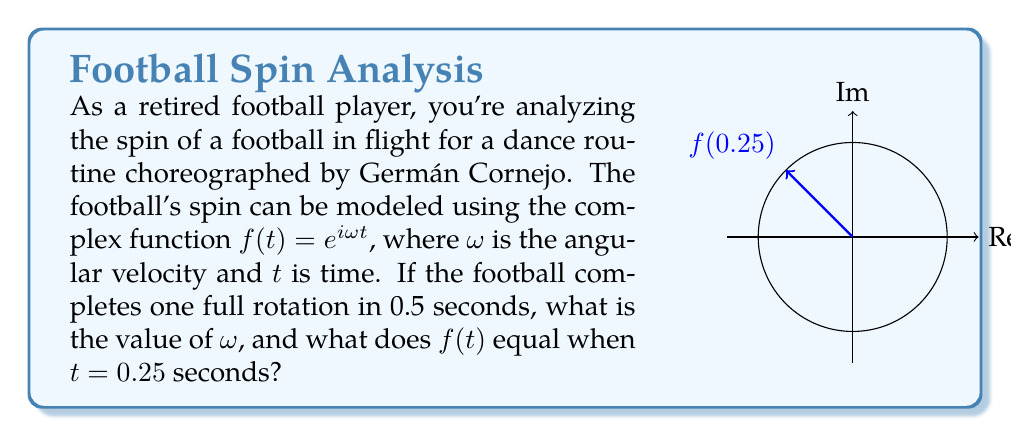Solve this math problem. Let's approach this step-by-step:

1) First, we need to find $\omega$. We know that one full rotation takes 0.5 seconds. In complex analysis, a full rotation corresponds to $2\pi$ radians.

2) So, we can set up the equation:
   $$\omega \cdot 0.5 = 2\pi$$

3) Solving for $\omega$:
   $$\omega = \frac{2\pi}{0.5} = 4\pi \text{ rad/s}$$

4) Now that we have $\omega$, we can write our function:
   $$f(t) = e^{i4\pi t}$$

5) To find $f(0.25)$, we simply substitute $t = 0.25$:
   $$f(0.25) = e^{i4\pi \cdot 0.25} = e^{i\pi} = -1$$

6) We can also express this in polar form:
   $$f(0.25) = \cos(\pi) + i\sin(\pi) = -1 + 0i$$

This result makes sense geometrically, as a quarter rotation of $2\pi$ is $\frac{\pi}{2}$, and $e^{i\pi}$ represents a half rotation, which puts us at $-1$ on the real axis of the complex plane.
Answer: $\omega = 4\pi \text{ rad/s}$; $f(0.25) = -1$ 